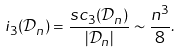<formula> <loc_0><loc_0><loc_500><loc_500>i _ { 3 } ( \mathcal { D } _ { n } ) = \frac { s c _ { 3 } ( \mathcal { D } _ { n } ) } { | \mathcal { D } _ { n } | } \sim \frac { n ^ { 3 } } { 8 } .</formula> 